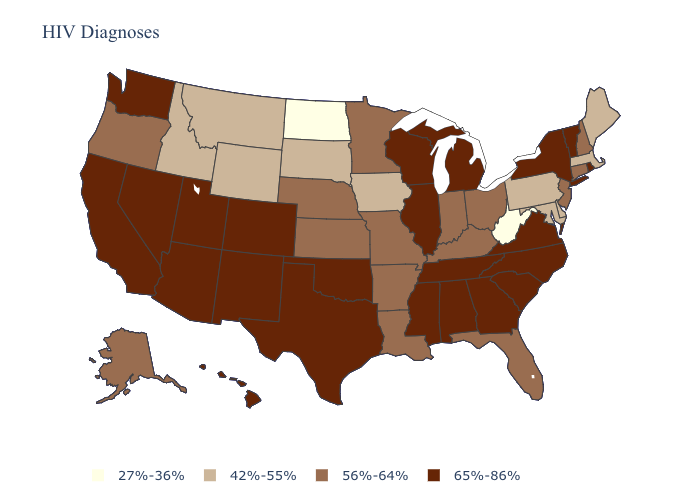Does Maine have the lowest value in the Northeast?
Keep it brief. Yes. Name the states that have a value in the range 65%-86%?
Concise answer only. Alabama, Arizona, California, Colorado, Georgia, Hawaii, Illinois, Michigan, Mississippi, Nevada, New Mexico, New York, North Carolina, Oklahoma, Rhode Island, South Carolina, Tennessee, Texas, Utah, Vermont, Virginia, Washington, Wisconsin. Name the states that have a value in the range 42%-55%?
Keep it brief. Delaware, Idaho, Iowa, Maine, Maryland, Massachusetts, Montana, Pennsylvania, South Dakota, Wyoming. What is the value of Colorado?
Be succinct. 65%-86%. Does North Dakota have the lowest value in the USA?
Give a very brief answer. Yes. Which states hav the highest value in the South?
Quick response, please. Alabama, Georgia, Mississippi, North Carolina, Oklahoma, South Carolina, Tennessee, Texas, Virginia. Name the states that have a value in the range 42%-55%?
Keep it brief. Delaware, Idaho, Iowa, Maine, Maryland, Massachusetts, Montana, Pennsylvania, South Dakota, Wyoming. What is the value of Oklahoma?
Be succinct. 65%-86%. What is the value of Arkansas?
Answer briefly. 56%-64%. What is the highest value in states that border North Dakota?
Write a very short answer. 56%-64%. What is the value of Ohio?
Answer briefly. 56%-64%. Among the states that border Iowa , does South Dakota have the lowest value?
Give a very brief answer. Yes. Does New Hampshire have a lower value than Nevada?
Write a very short answer. Yes. Name the states that have a value in the range 65%-86%?
Concise answer only. Alabama, Arizona, California, Colorado, Georgia, Hawaii, Illinois, Michigan, Mississippi, Nevada, New Mexico, New York, North Carolina, Oklahoma, Rhode Island, South Carolina, Tennessee, Texas, Utah, Vermont, Virginia, Washington, Wisconsin. What is the lowest value in states that border Kansas?
Short answer required. 56%-64%. 